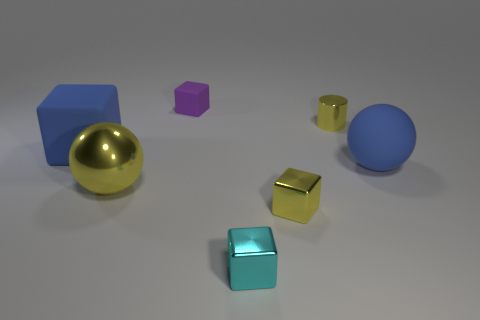Add 1 blue spheres. How many objects exist? 8 Subtract all brown cubes. Subtract all cyan cylinders. How many cubes are left? 4 Subtract all cylinders. How many objects are left? 6 Subtract all small rubber things. Subtract all large matte things. How many objects are left? 4 Add 3 matte balls. How many matte balls are left? 4 Add 4 small yellow things. How many small yellow things exist? 6 Subtract 0 red blocks. How many objects are left? 7 